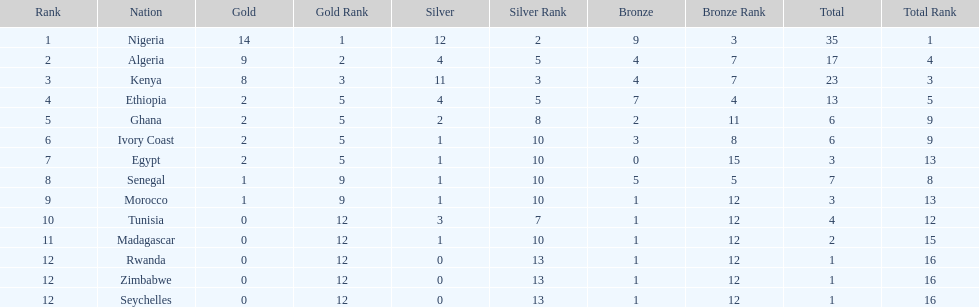The team with the most gold medals Nigeria. 